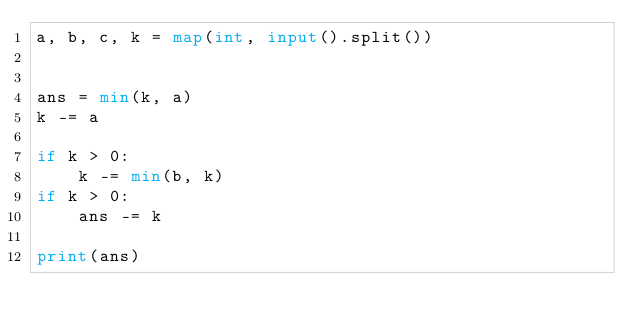Convert code to text. <code><loc_0><loc_0><loc_500><loc_500><_Python_>a, b, c, k = map(int, input().split())


ans = min(k, a)
k -= a

if k > 0:
	k -= min(b, k)
if k > 0:
	ans -= k

print(ans)</code> 